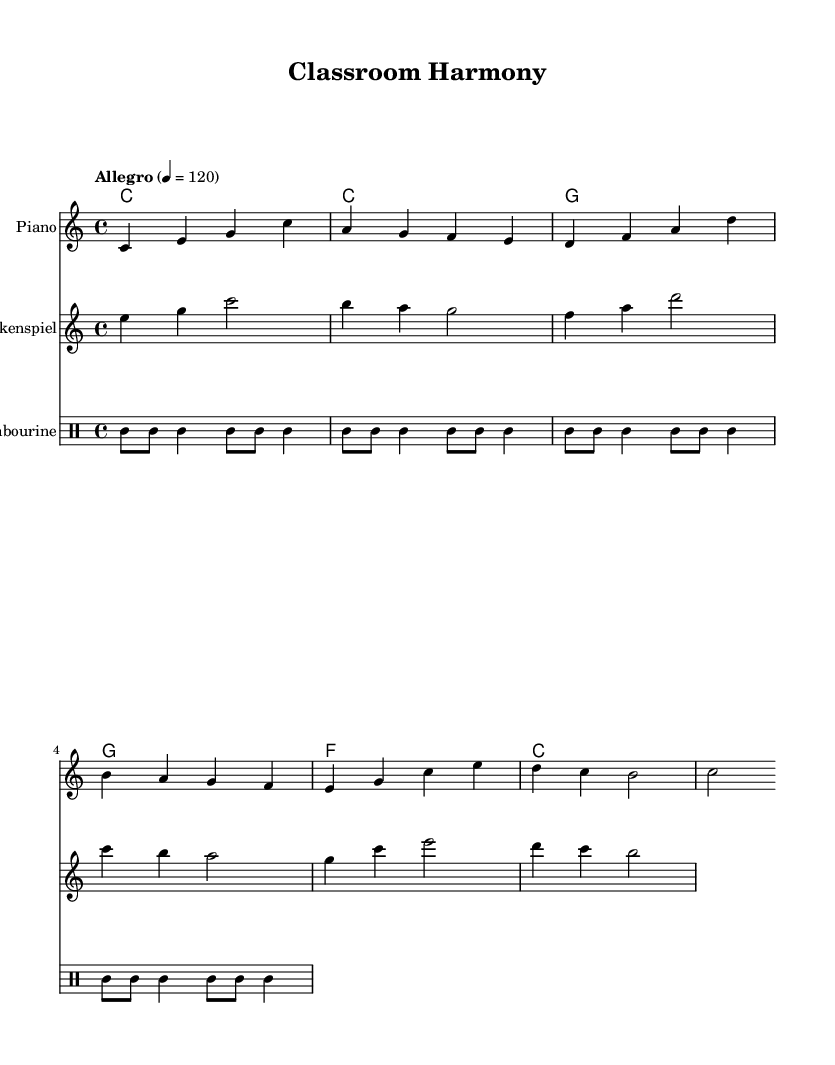What is the key signature of this music? The key signature is indicated by the absence of sharps or flats, which corresponds to C major.
Answer: C major What is the time signature of this music? The time signature is shown at the beginning of the score and is notated as 4 over 4, meaning there are four beats in each measure.
Answer: 4/4 What is the tempo marking for this piece? The tempo marking is given as "Allegro," and the specific tempo is indicated with a number showing beats per minute, which is 120.
Answer: Allegro, 120 How many measures are included in the piano part? By counting the measures in the piano notation, there are a total of 8 measures present in the excerpt.
Answer: 8 Which instruments are used in this piece? The instruments are specified at the beginning of each staff. There are three instruments: Piano, Glockenspiel, and Tambourine.
Answer: Piano, Glockenspiel, Tambourine What pattern is used for the tambourine? The tambourine part follows a repeating rhythmic pattern, specifically a combination of eighth notes and quarter notes, which can be identified in the drum notation.
Answer: Tamb (tambourine pattern) 